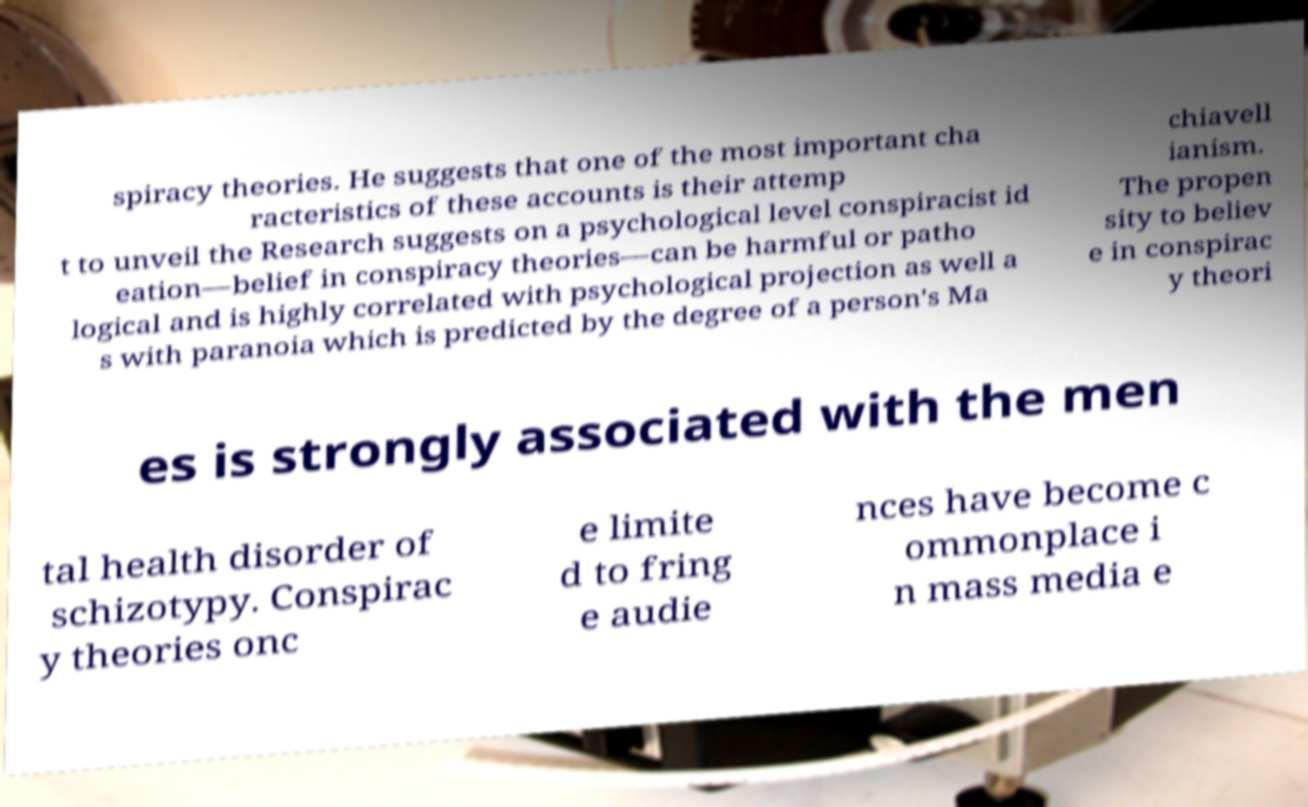Please identify and transcribe the text found in this image. spiracy theories. He suggests that one of the most important cha racteristics of these accounts is their attemp t to unveil the Research suggests on a psychological level conspiracist id eation—belief in conspiracy theories—can be harmful or patho logical and is highly correlated with psychological projection as well a s with paranoia which is predicted by the degree of a person's Ma chiavell ianism. The propen sity to believ e in conspirac y theori es is strongly associated with the men tal health disorder of schizotypy. Conspirac y theories onc e limite d to fring e audie nces have become c ommonplace i n mass media e 